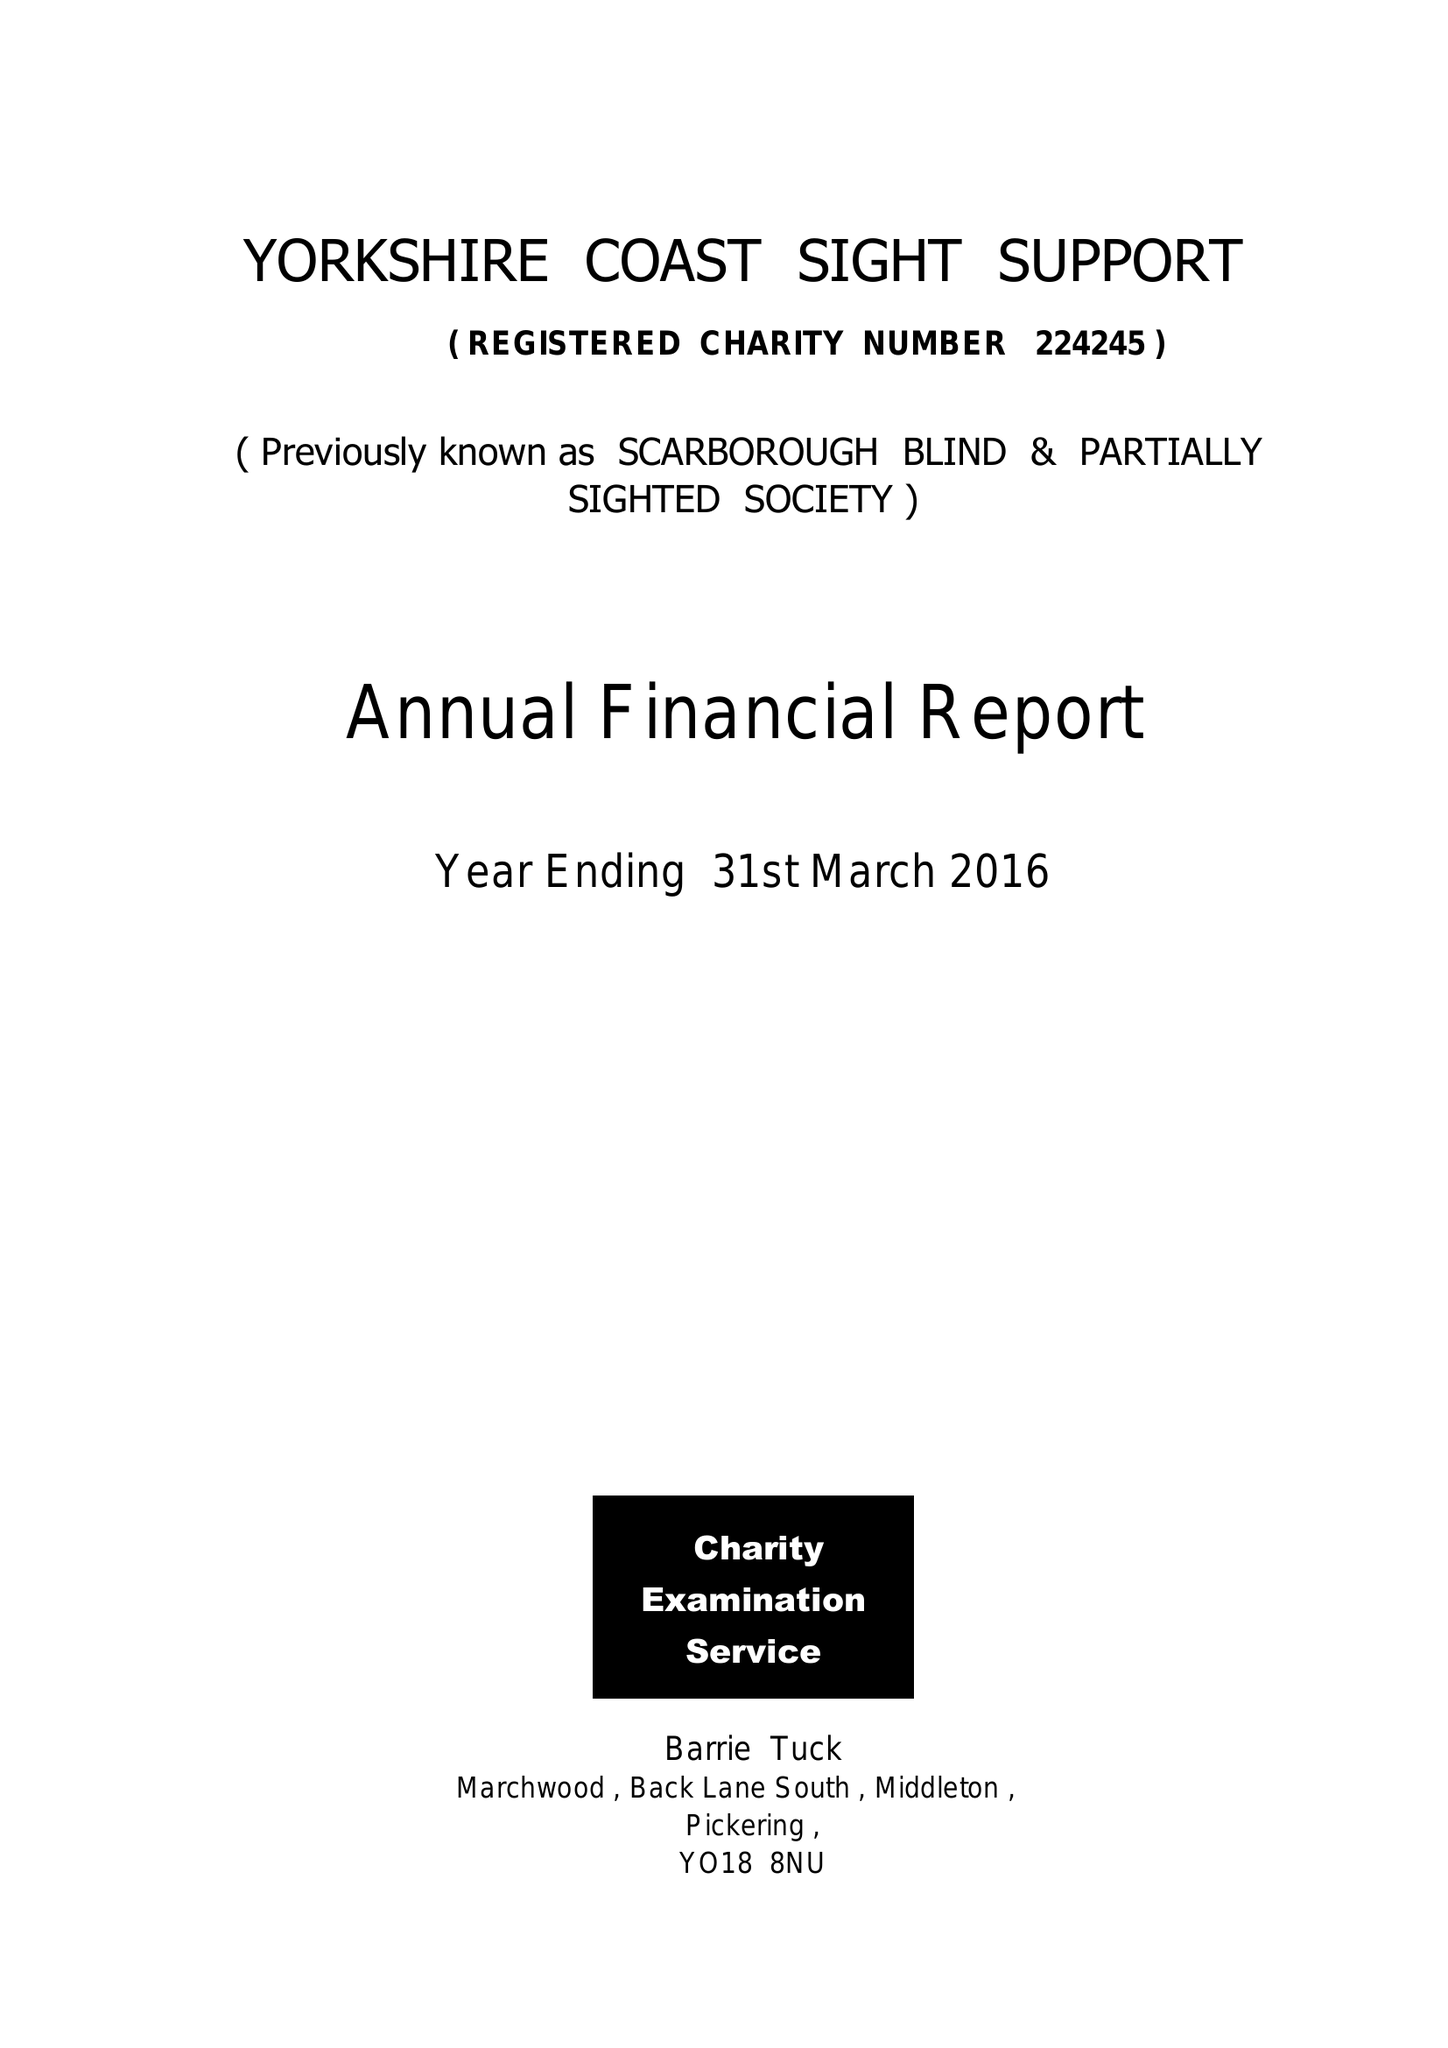What is the value for the spending_annually_in_british_pounds?
Answer the question using a single word or phrase. 94745.00 